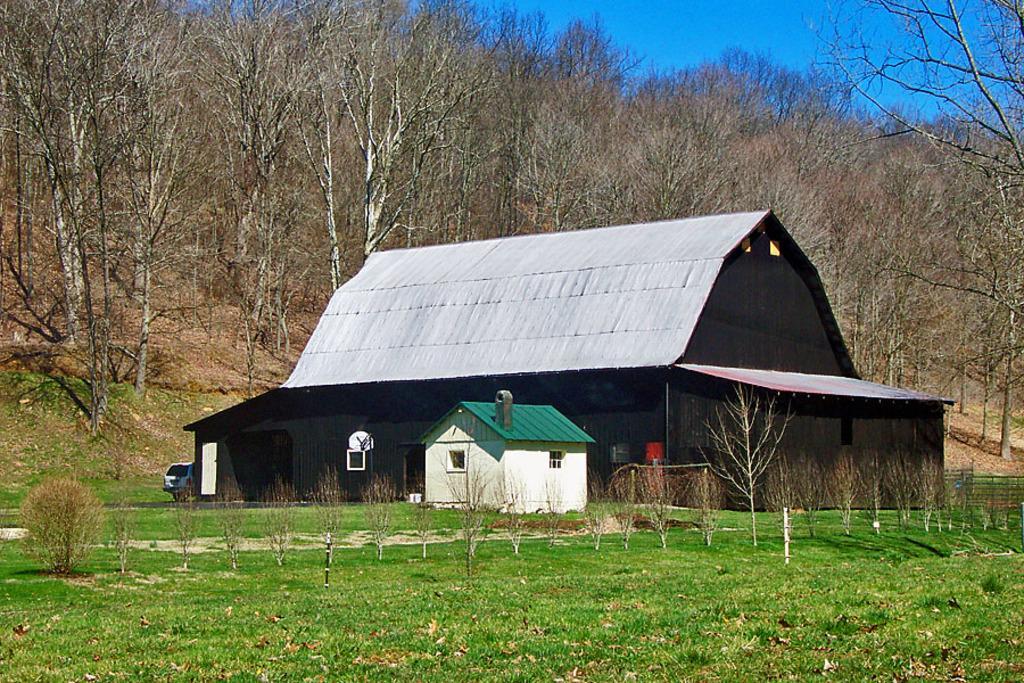Can you describe this image briefly? There is grass and there are plants on the ground. In the background, there is a shelter near a shed, there is a vehicle on the ground, there are trees on the hill and there is blue sky. 